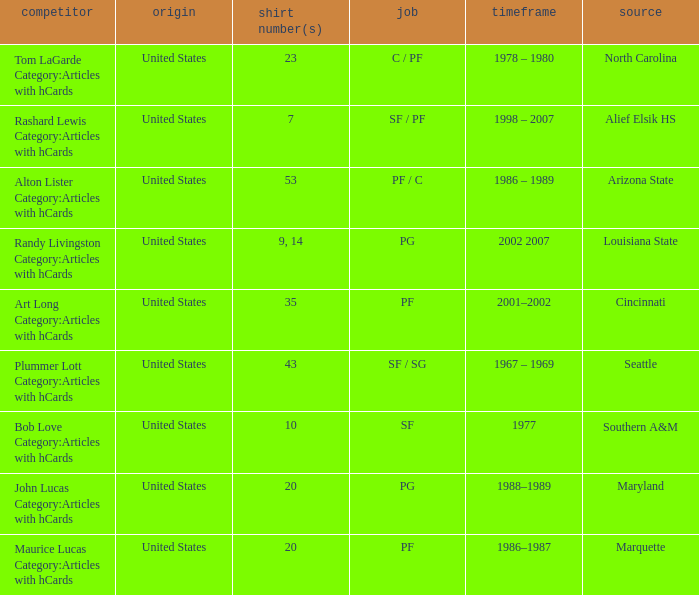The player from Alief Elsik Hs has what as a nationality? United States. 